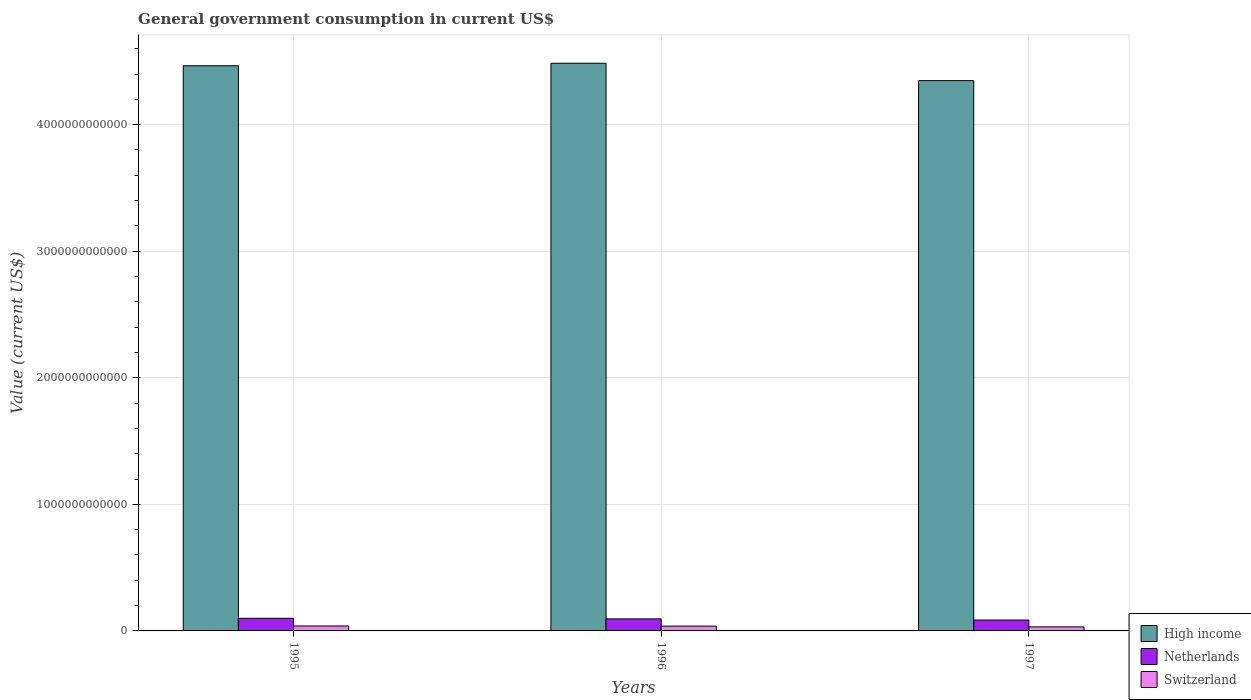How many different coloured bars are there?
Your response must be concise. 3. How many groups of bars are there?
Your answer should be very brief. 3. Are the number of bars on each tick of the X-axis equal?
Give a very brief answer. Yes. How many bars are there on the 1st tick from the left?
Your answer should be very brief. 3. How many bars are there on the 1st tick from the right?
Provide a succinct answer. 3. What is the government conusmption in High income in 1997?
Your answer should be very brief. 4.35e+12. Across all years, what is the maximum government conusmption in Switzerland?
Offer a very short reply. 3.90e+1. Across all years, what is the minimum government conusmption in High income?
Ensure brevity in your answer.  4.35e+12. In which year was the government conusmption in Netherlands minimum?
Provide a short and direct response. 1997. What is the total government conusmption in Netherlands in the graph?
Ensure brevity in your answer.  2.81e+11. What is the difference between the government conusmption in Netherlands in 1995 and that in 1997?
Give a very brief answer. 1.38e+1. What is the difference between the government conusmption in Netherlands in 1997 and the government conusmption in High income in 1995?
Keep it short and to the point. -4.38e+12. What is the average government conusmption in High income per year?
Your response must be concise. 4.43e+12. In the year 1997, what is the difference between the government conusmption in Netherlands and government conusmption in High income?
Your answer should be compact. -4.26e+12. What is the ratio of the government conusmption in Netherlands in 1995 to that in 1997?
Make the answer very short. 1.16. Is the difference between the government conusmption in Netherlands in 1996 and 1997 greater than the difference between the government conusmption in High income in 1996 and 1997?
Make the answer very short. No. What is the difference between the highest and the second highest government conusmption in High income?
Your response must be concise. 1.97e+1. What is the difference between the highest and the lowest government conusmption in Switzerland?
Your answer should be compact. 6.99e+09. How many bars are there?
Your response must be concise. 9. Are all the bars in the graph horizontal?
Provide a succinct answer. No. How many years are there in the graph?
Keep it short and to the point. 3. What is the difference between two consecutive major ticks on the Y-axis?
Offer a terse response. 1.00e+12. Does the graph contain grids?
Offer a very short reply. Yes. Where does the legend appear in the graph?
Provide a short and direct response. Bottom right. How many legend labels are there?
Your response must be concise. 3. What is the title of the graph?
Make the answer very short. General government consumption in current US$. What is the label or title of the Y-axis?
Your answer should be very brief. Value (current US$). What is the Value (current US$) of High income in 1995?
Offer a very short reply. 4.47e+12. What is the Value (current US$) in Netherlands in 1995?
Make the answer very short. 9.99e+1. What is the Value (current US$) of Switzerland in 1995?
Keep it short and to the point. 3.90e+1. What is the Value (current US$) in High income in 1996?
Your answer should be very brief. 4.49e+12. What is the Value (current US$) of Netherlands in 1996?
Make the answer very short. 9.52e+1. What is the Value (current US$) of Switzerland in 1996?
Offer a terse response. 3.79e+1. What is the Value (current US$) in High income in 1997?
Provide a succinct answer. 4.35e+12. What is the Value (current US$) of Netherlands in 1997?
Provide a short and direct response. 8.61e+1. What is the Value (current US$) of Switzerland in 1997?
Your answer should be very brief. 3.20e+1. Across all years, what is the maximum Value (current US$) of High income?
Make the answer very short. 4.49e+12. Across all years, what is the maximum Value (current US$) in Netherlands?
Offer a very short reply. 9.99e+1. Across all years, what is the maximum Value (current US$) in Switzerland?
Give a very brief answer. 3.90e+1. Across all years, what is the minimum Value (current US$) of High income?
Your answer should be very brief. 4.35e+12. Across all years, what is the minimum Value (current US$) in Netherlands?
Your answer should be very brief. 8.61e+1. Across all years, what is the minimum Value (current US$) in Switzerland?
Your answer should be very brief. 3.20e+1. What is the total Value (current US$) of High income in the graph?
Ensure brevity in your answer.  1.33e+13. What is the total Value (current US$) of Netherlands in the graph?
Provide a succinct answer. 2.81e+11. What is the total Value (current US$) of Switzerland in the graph?
Provide a succinct answer. 1.09e+11. What is the difference between the Value (current US$) in High income in 1995 and that in 1996?
Provide a short and direct response. -1.97e+1. What is the difference between the Value (current US$) of Netherlands in 1995 and that in 1996?
Keep it short and to the point. 4.68e+09. What is the difference between the Value (current US$) of Switzerland in 1995 and that in 1996?
Ensure brevity in your answer.  1.10e+09. What is the difference between the Value (current US$) in High income in 1995 and that in 1997?
Your answer should be very brief. 1.18e+11. What is the difference between the Value (current US$) in Netherlands in 1995 and that in 1997?
Make the answer very short. 1.38e+1. What is the difference between the Value (current US$) in Switzerland in 1995 and that in 1997?
Give a very brief answer. 6.99e+09. What is the difference between the Value (current US$) in High income in 1996 and that in 1997?
Make the answer very short. 1.37e+11. What is the difference between the Value (current US$) of Netherlands in 1996 and that in 1997?
Make the answer very short. 9.09e+09. What is the difference between the Value (current US$) of Switzerland in 1996 and that in 1997?
Offer a very short reply. 5.89e+09. What is the difference between the Value (current US$) in High income in 1995 and the Value (current US$) in Netherlands in 1996?
Keep it short and to the point. 4.37e+12. What is the difference between the Value (current US$) of High income in 1995 and the Value (current US$) of Switzerland in 1996?
Provide a succinct answer. 4.43e+12. What is the difference between the Value (current US$) in Netherlands in 1995 and the Value (current US$) in Switzerland in 1996?
Ensure brevity in your answer.  6.20e+1. What is the difference between the Value (current US$) in High income in 1995 and the Value (current US$) in Netherlands in 1997?
Your response must be concise. 4.38e+12. What is the difference between the Value (current US$) in High income in 1995 and the Value (current US$) in Switzerland in 1997?
Make the answer very short. 4.43e+12. What is the difference between the Value (current US$) of Netherlands in 1995 and the Value (current US$) of Switzerland in 1997?
Provide a short and direct response. 6.79e+1. What is the difference between the Value (current US$) in High income in 1996 and the Value (current US$) in Netherlands in 1997?
Your answer should be compact. 4.40e+12. What is the difference between the Value (current US$) in High income in 1996 and the Value (current US$) in Switzerland in 1997?
Your answer should be compact. 4.45e+12. What is the difference between the Value (current US$) of Netherlands in 1996 and the Value (current US$) of Switzerland in 1997?
Your response must be concise. 6.32e+1. What is the average Value (current US$) in High income per year?
Your response must be concise. 4.43e+12. What is the average Value (current US$) of Netherlands per year?
Give a very brief answer. 9.38e+1. What is the average Value (current US$) of Switzerland per year?
Your answer should be compact. 3.63e+1. In the year 1995, what is the difference between the Value (current US$) of High income and Value (current US$) of Netherlands?
Keep it short and to the point. 4.37e+12. In the year 1995, what is the difference between the Value (current US$) of High income and Value (current US$) of Switzerland?
Make the answer very short. 4.43e+12. In the year 1995, what is the difference between the Value (current US$) of Netherlands and Value (current US$) of Switzerland?
Your answer should be very brief. 6.09e+1. In the year 1996, what is the difference between the Value (current US$) in High income and Value (current US$) in Netherlands?
Your answer should be compact. 4.39e+12. In the year 1996, what is the difference between the Value (current US$) of High income and Value (current US$) of Switzerland?
Offer a terse response. 4.45e+12. In the year 1996, what is the difference between the Value (current US$) of Netherlands and Value (current US$) of Switzerland?
Offer a terse response. 5.73e+1. In the year 1997, what is the difference between the Value (current US$) of High income and Value (current US$) of Netherlands?
Ensure brevity in your answer.  4.26e+12. In the year 1997, what is the difference between the Value (current US$) in High income and Value (current US$) in Switzerland?
Give a very brief answer. 4.32e+12. In the year 1997, what is the difference between the Value (current US$) in Netherlands and Value (current US$) in Switzerland?
Keep it short and to the point. 5.41e+1. What is the ratio of the Value (current US$) of Netherlands in 1995 to that in 1996?
Offer a very short reply. 1.05. What is the ratio of the Value (current US$) in Switzerland in 1995 to that in 1996?
Provide a succinct answer. 1.03. What is the ratio of the Value (current US$) of High income in 1995 to that in 1997?
Give a very brief answer. 1.03. What is the ratio of the Value (current US$) of Netherlands in 1995 to that in 1997?
Make the answer very short. 1.16. What is the ratio of the Value (current US$) of Switzerland in 1995 to that in 1997?
Your answer should be very brief. 1.22. What is the ratio of the Value (current US$) of High income in 1996 to that in 1997?
Keep it short and to the point. 1.03. What is the ratio of the Value (current US$) of Netherlands in 1996 to that in 1997?
Ensure brevity in your answer.  1.11. What is the ratio of the Value (current US$) of Switzerland in 1996 to that in 1997?
Provide a short and direct response. 1.18. What is the difference between the highest and the second highest Value (current US$) in High income?
Your response must be concise. 1.97e+1. What is the difference between the highest and the second highest Value (current US$) of Netherlands?
Ensure brevity in your answer.  4.68e+09. What is the difference between the highest and the second highest Value (current US$) of Switzerland?
Your response must be concise. 1.10e+09. What is the difference between the highest and the lowest Value (current US$) in High income?
Make the answer very short. 1.37e+11. What is the difference between the highest and the lowest Value (current US$) in Netherlands?
Offer a terse response. 1.38e+1. What is the difference between the highest and the lowest Value (current US$) in Switzerland?
Keep it short and to the point. 6.99e+09. 